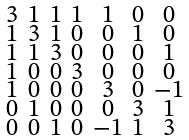<formula> <loc_0><loc_0><loc_500><loc_500>\begin{smallmatrix} 3 & 1 & 1 & 1 & 1 & 0 & 0 \\ 1 & 3 & 1 & 0 & 0 & 1 & 0 \\ 1 & 1 & 3 & 0 & 0 & 0 & 1 \\ 1 & 0 & 0 & 3 & 0 & 0 & 0 \\ 1 & 0 & 0 & 0 & 3 & 0 & - 1 \\ 0 & 1 & 0 & 0 & 0 & 3 & 1 \\ 0 & 0 & 1 & 0 & - 1 & 1 & 3 \end{smallmatrix}</formula> 